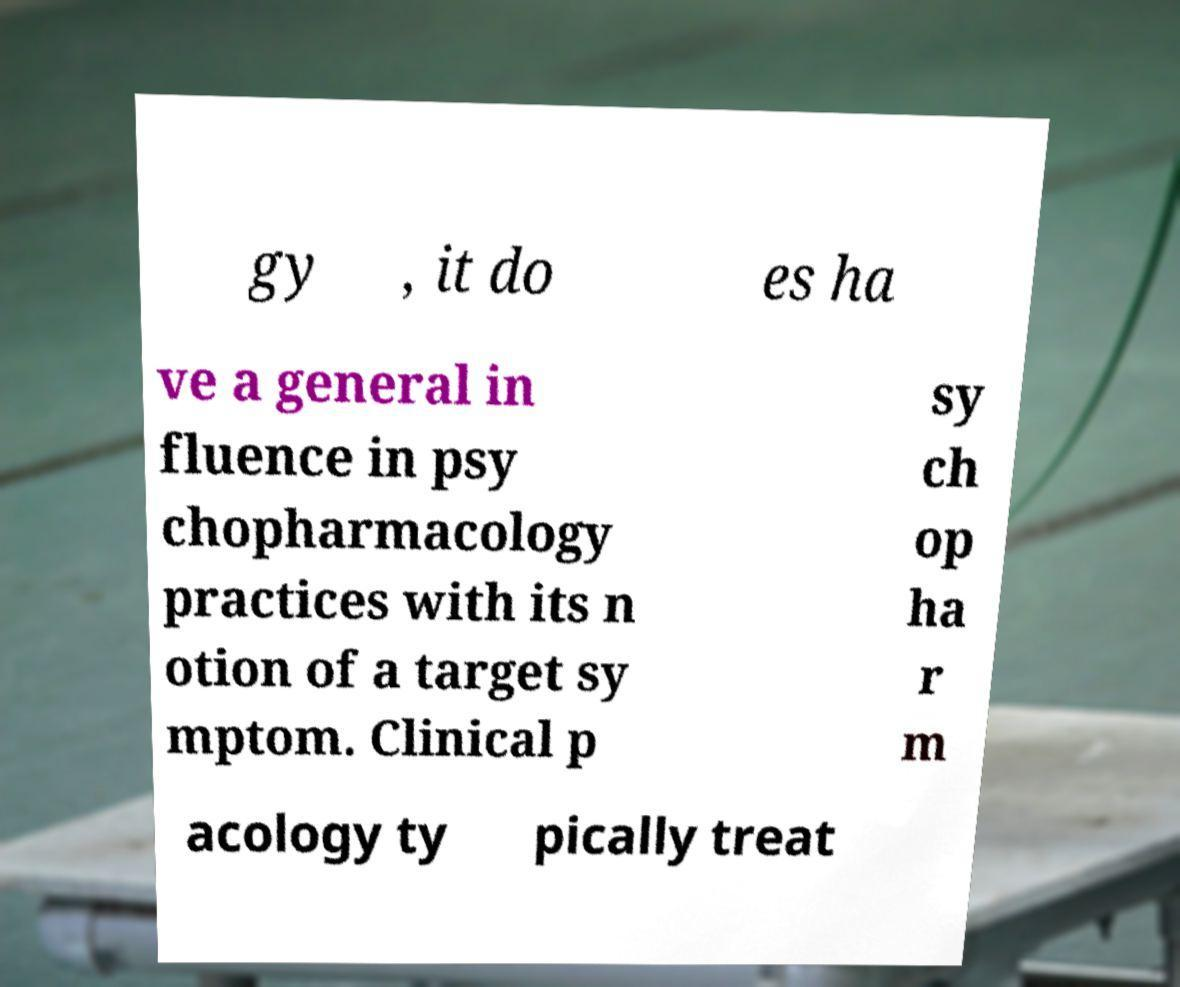For documentation purposes, I need the text within this image transcribed. Could you provide that? gy , it do es ha ve a general in fluence in psy chopharmacology practices with its n otion of a target sy mptom. Clinical p sy ch op ha r m acology ty pically treat 